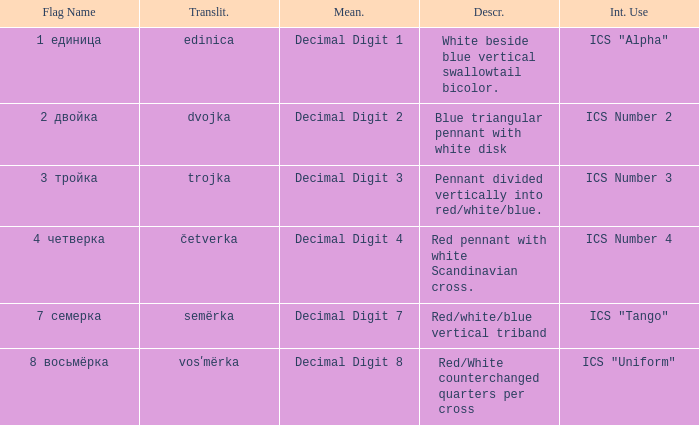What are the meanings of the flag whose name transliterates to semërka? Decimal Digit 7. Can you parse all the data within this table? {'header': ['Flag Name', 'Translit.', 'Mean.', 'Descr.', 'Int. Use'], 'rows': [['1 единица', 'edinica', 'Decimal Digit 1', 'White beside blue vertical swallowtail bicolor.', 'ICS "Alpha"'], ['2 двойка', 'dvojka', 'Decimal Digit 2', 'Blue triangular pennant with white disk', 'ICS Number 2'], ['3 тройка', 'trojka', 'Decimal Digit 3', 'Pennant divided vertically into red/white/blue.', 'ICS Number 3'], ['4 четверка', 'četverka', 'Decimal Digit 4', 'Red pennant with white Scandinavian cross.', 'ICS Number 4'], ['7 семерка', 'semërka', 'Decimal Digit 7', 'Red/white/blue vertical triband', 'ICS "Tango"'], ['8 восьмёрка', 'vosʹmërka', 'Decimal Digit 8', 'Red/White counterchanged quarters per cross', 'ICS "Uniform"']]} 